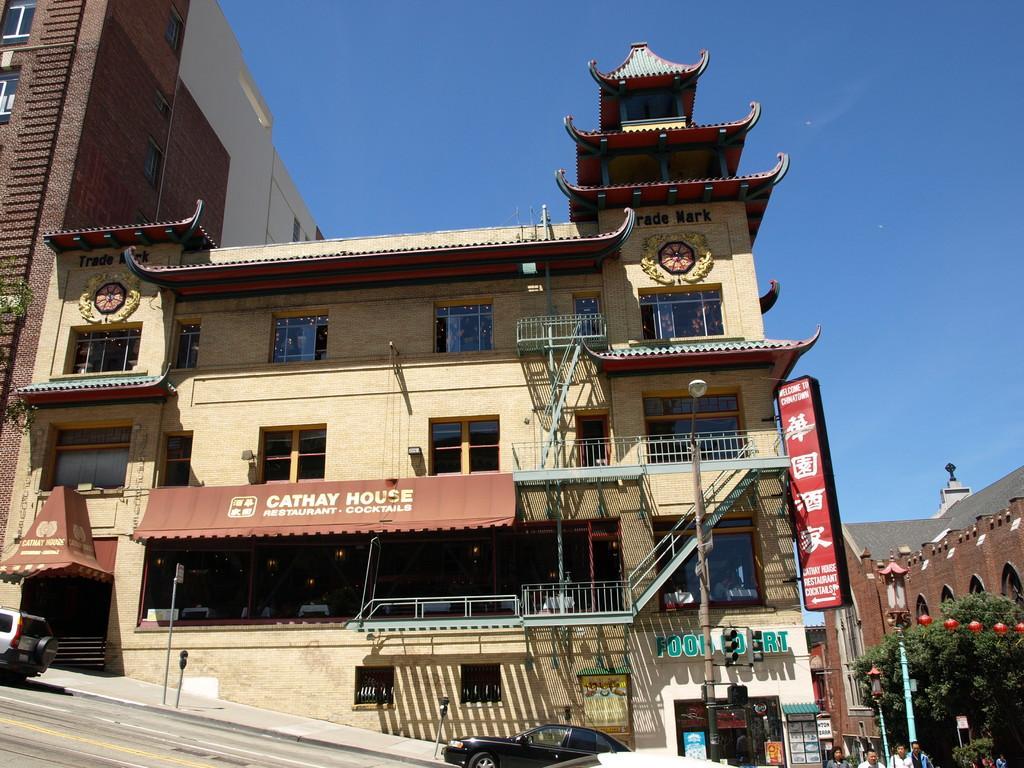Describe this image in one or two sentences. On the left side, there is a vehicle on the road. On the right side, there is a vehicle and there are persons. In the background, there are buildings, trees, hoardings and there is a blue sky. 